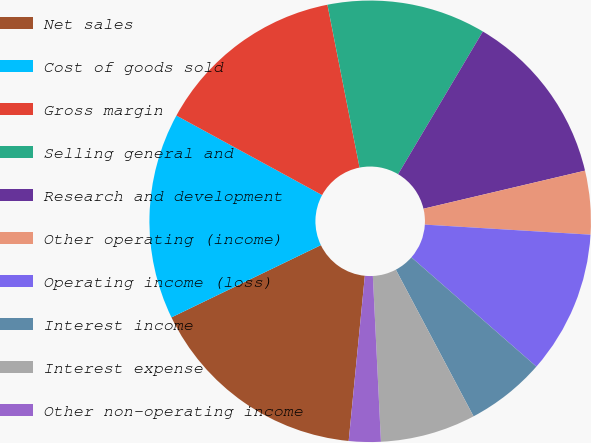Convert chart to OTSL. <chart><loc_0><loc_0><loc_500><loc_500><pie_chart><fcel>Net sales<fcel>Cost of goods sold<fcel>Gross margin<fcel>Selling general and<fcel>Research and development<fcel>Other operating (income)<fcel>Operating income (loss)<fcel>Interest income<fcel>Interest expense<fcel>Other non-operating income<nl><fcel>16.28%<fcel>15.12%<fcel>13.95%<fcel>11.63%<fcel>12.79%<fcel>4.65%<fcel>10.47%<fcel>5.81%<fcel>6.98%<fcel>2.33%<nl></chart> 